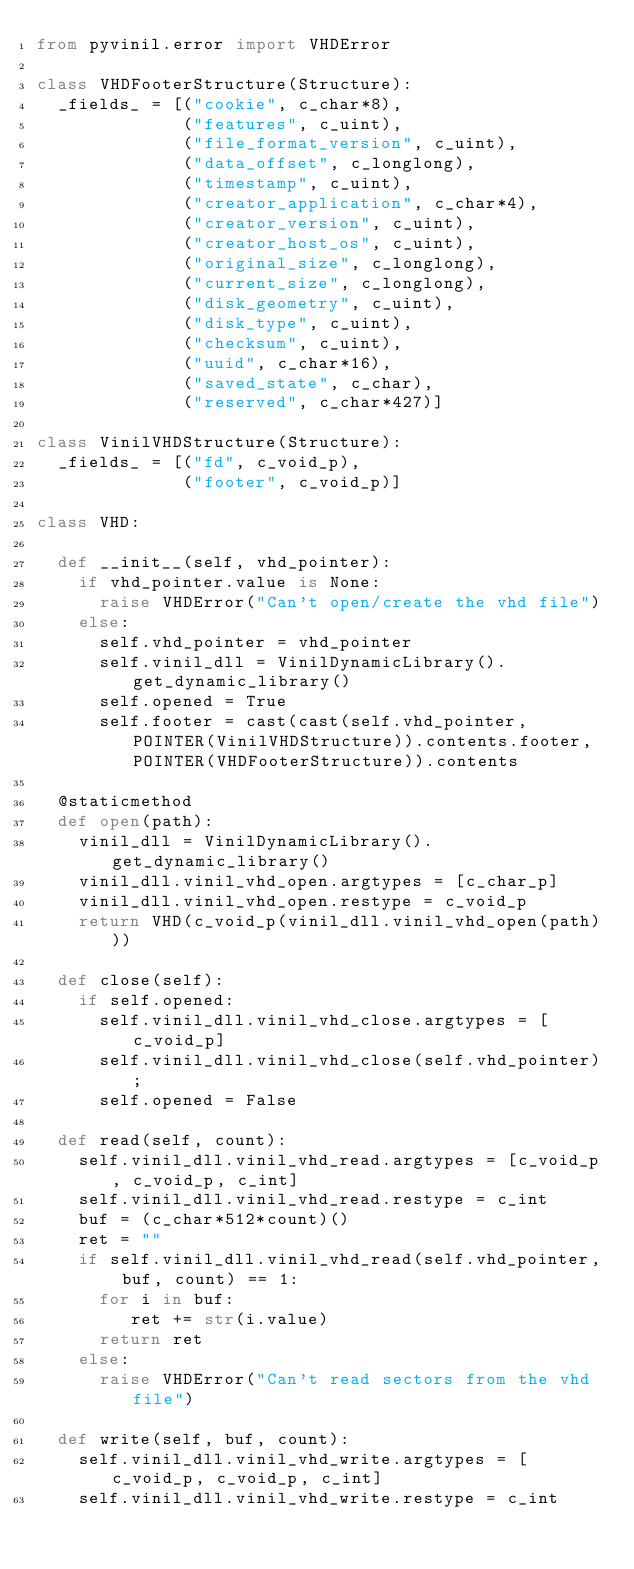Convert code to text. <code><loc_0><loc_0><loc_500><loc_500><_Python_>from pyvinil.error import VHDError

class VHDFooterStructure(Structure):
  _fields_ = [("cookie", c_char*8),
              ("features", c_uint),
              ("file_format_version", c_uint),
              ("data_offset", c_longlong),
              ("timestamp", c_uint),
              ("creator_application", c_char*4),
              ("creator_version", c_uint),
              ("creator_host_os", c_uint),
              ("original_size", c_longlong),
              ("current_size", c_longlong),
              ("disk_geometry", c_uint),
              ("disk_type", c_uint),
              ("checksum", c_uint),
              ("uuid", c_char*16),
              ("saved_state", c_char),
              ("reserved", c_char*427)]
              
class VinilVHDStructure(Structure):
  _fields_ = [("fd", c_void_p),
              ("footer", c_void_p)]

class VHD:
  
  def __init__(self, vhd_pointer):
    if vhd_pointer.value is None:
      raise VHDError("Can't open/create the vhd file")
    else:
      self.vhd_pointer = vhd_pointer
      self.vinil_dll = VinilDynamicLibrary().get_dynamic_library()
      self.opened = True
      self.footer = cast(cast(self.vhd_pointer, POINTER(VinilVHDStructure)).contents.footer, POINTER(VHDFooterStructure)).contents
  
  @staticmethod
  def open(path):
    vinil_dll = VinilDynamicLibrary().get_dynamic_library()
    vinil_dll.vinil_vhd_open.argtypes = [c_char_p]
    vinil_dll.vinil_vhd_open.restype = c_void_p
    return VHD(c_void_p(vinil_dll.vinil_vhd_open(path)))
  
  def close(self):
    if self.opened:
      self.vinil_dll.vinil_vhd_close.argtypes = [c_void_p]
      self.vinil_dll.vinil_vhd_close(self.vhd_pointer);
      self.opened = False
    
  def read(self, count):
    self.vinil_dll.vinil_vhd_read.argtypes = [c_void_p, c_void_p, c_int]
    self.vinil_dll.vinil_vhd_read.restype = c_int
    buf = (c_char*512*count)()
    ret = ""
    if self.vinil_dll.vinil_vhd_read(self.vhd_pointer, buf, count) == 1:
      for i in buf:
         ret += str(i.value)
      return ret
    else:
      raise VHDError("Can't read sectors from the vhd file")
    
  def write(self, buf, count):
    self.vinil_dll.vinil_vhd_write.argtypes = [c_void_p, c_void_p, c_int]
    self.vinil_dll.vinil_vhd_write.restype = c_int</code> 